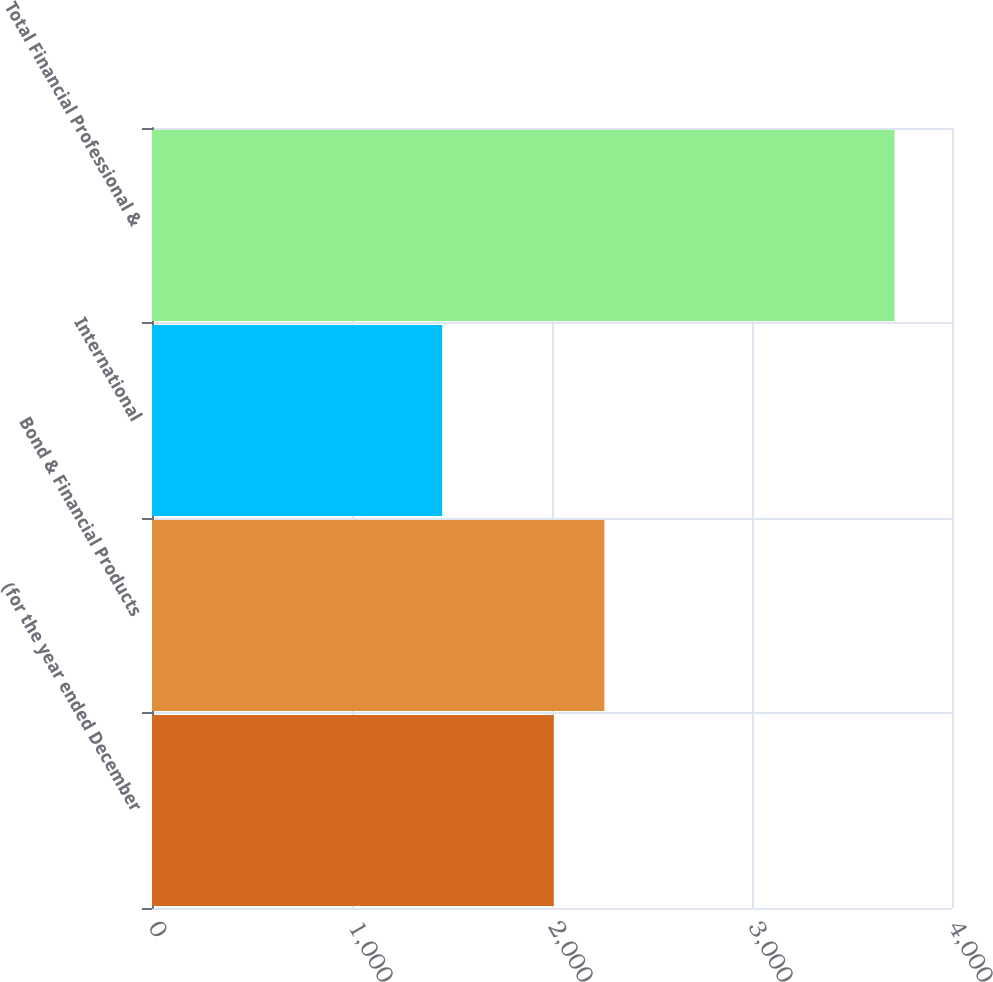Convert chart. <chart><loc_0><loc_0><loc_500><loc_500><bar_chart><fcel>(for the year ended December<fcel>Bond & Financial Products<fcel>International<fcel>Total Financial Professional &<nl><fcel>2009<fcel>2262<fcel>1451<fcel>3713<nl></chart> 